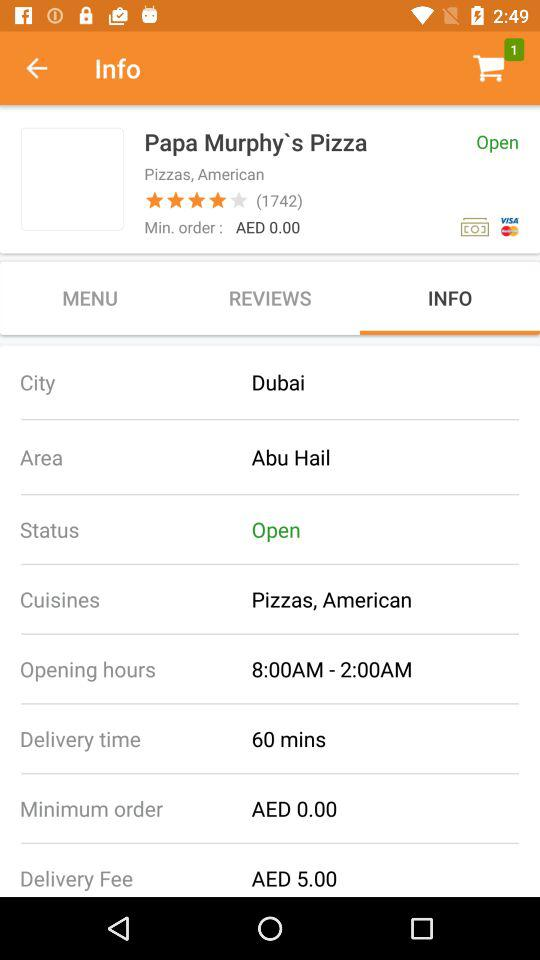What is the status of the store? The status of the store is "Open". 